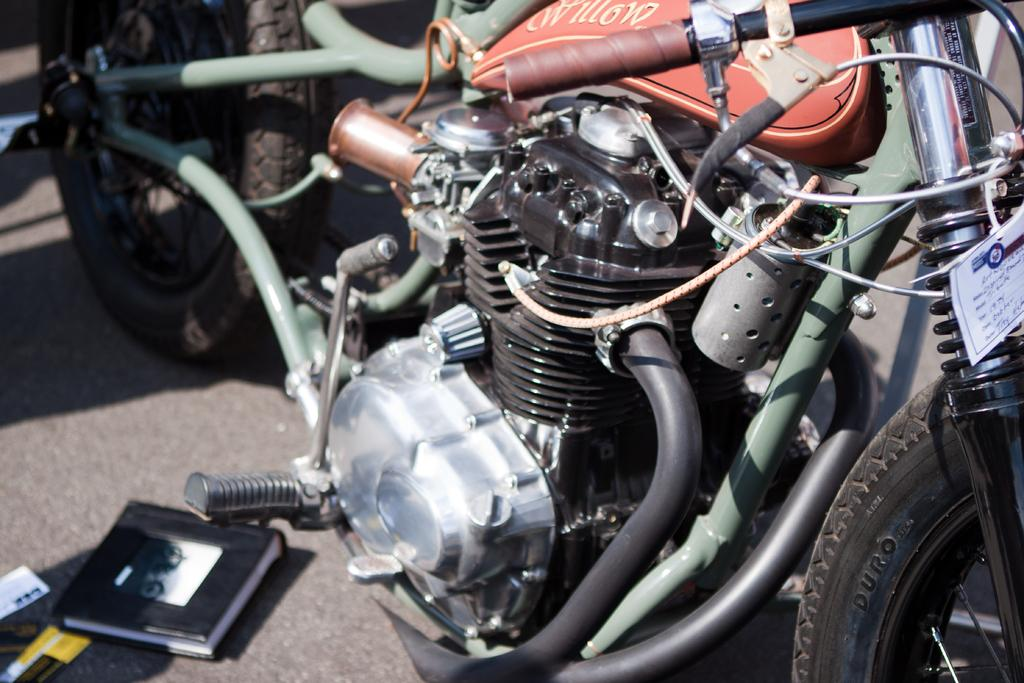What type of vehicles are in the image? There are motorcycles in the image. What other object can be seen in the image besides the motorcycles? There is a book in the image. Where is the cactus located in the image? There is no cactus present in the image. How many years has the lift been in operation in the image? There is no lift present in the image, so it is not possible to determine how many years it has been in operation. 